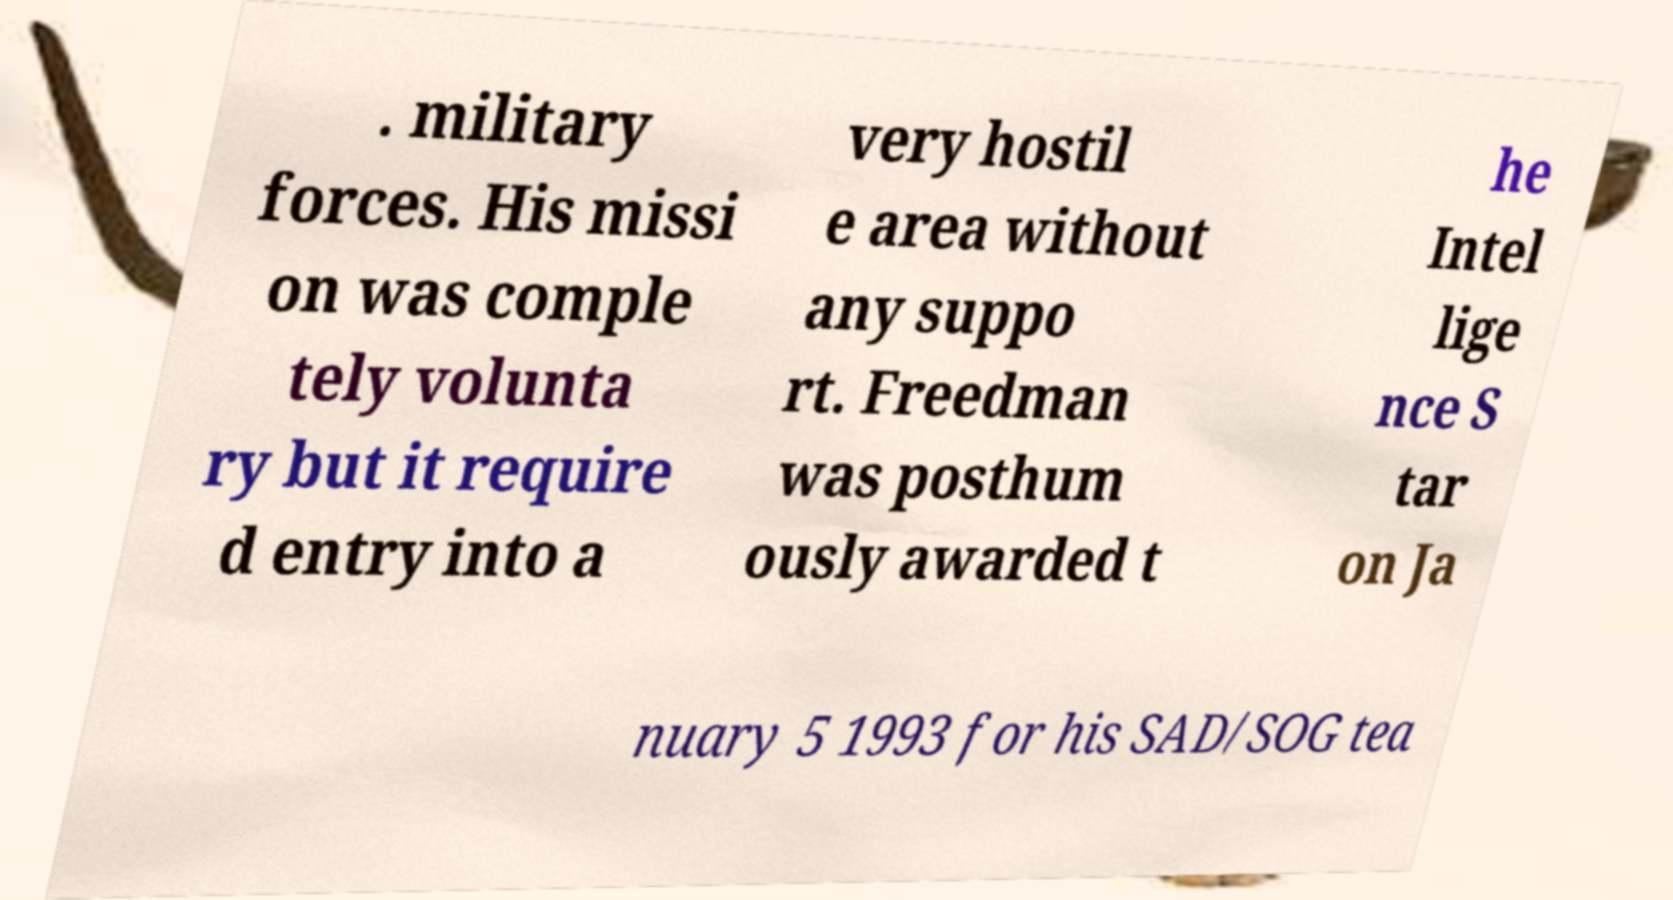What messages or text are displayed in this image? I need them in a readable, typed format. . military forces. His missi on was comple tely volunta ry but it require d entry into a very hostil e area without any suppo rt. Freedman was posthum ously awarded t he Intel lige nce S tar on Ja nuary 5 1993 for his SAD/SOG tea 